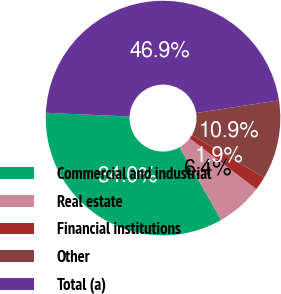Convert chart. <chart><loc_0><loc_0><loc_500><loc_500><pie_chart><fcel>Commercial and industrial<fcel>Real estate<fcel>Financial institutions<fcel>Other<fcel>Total (a)<nl><fcel>33.99%<fcel>6.38%<fcel>1.89%<fcel>10.88%<fcel>46.86%<nl></chart> 